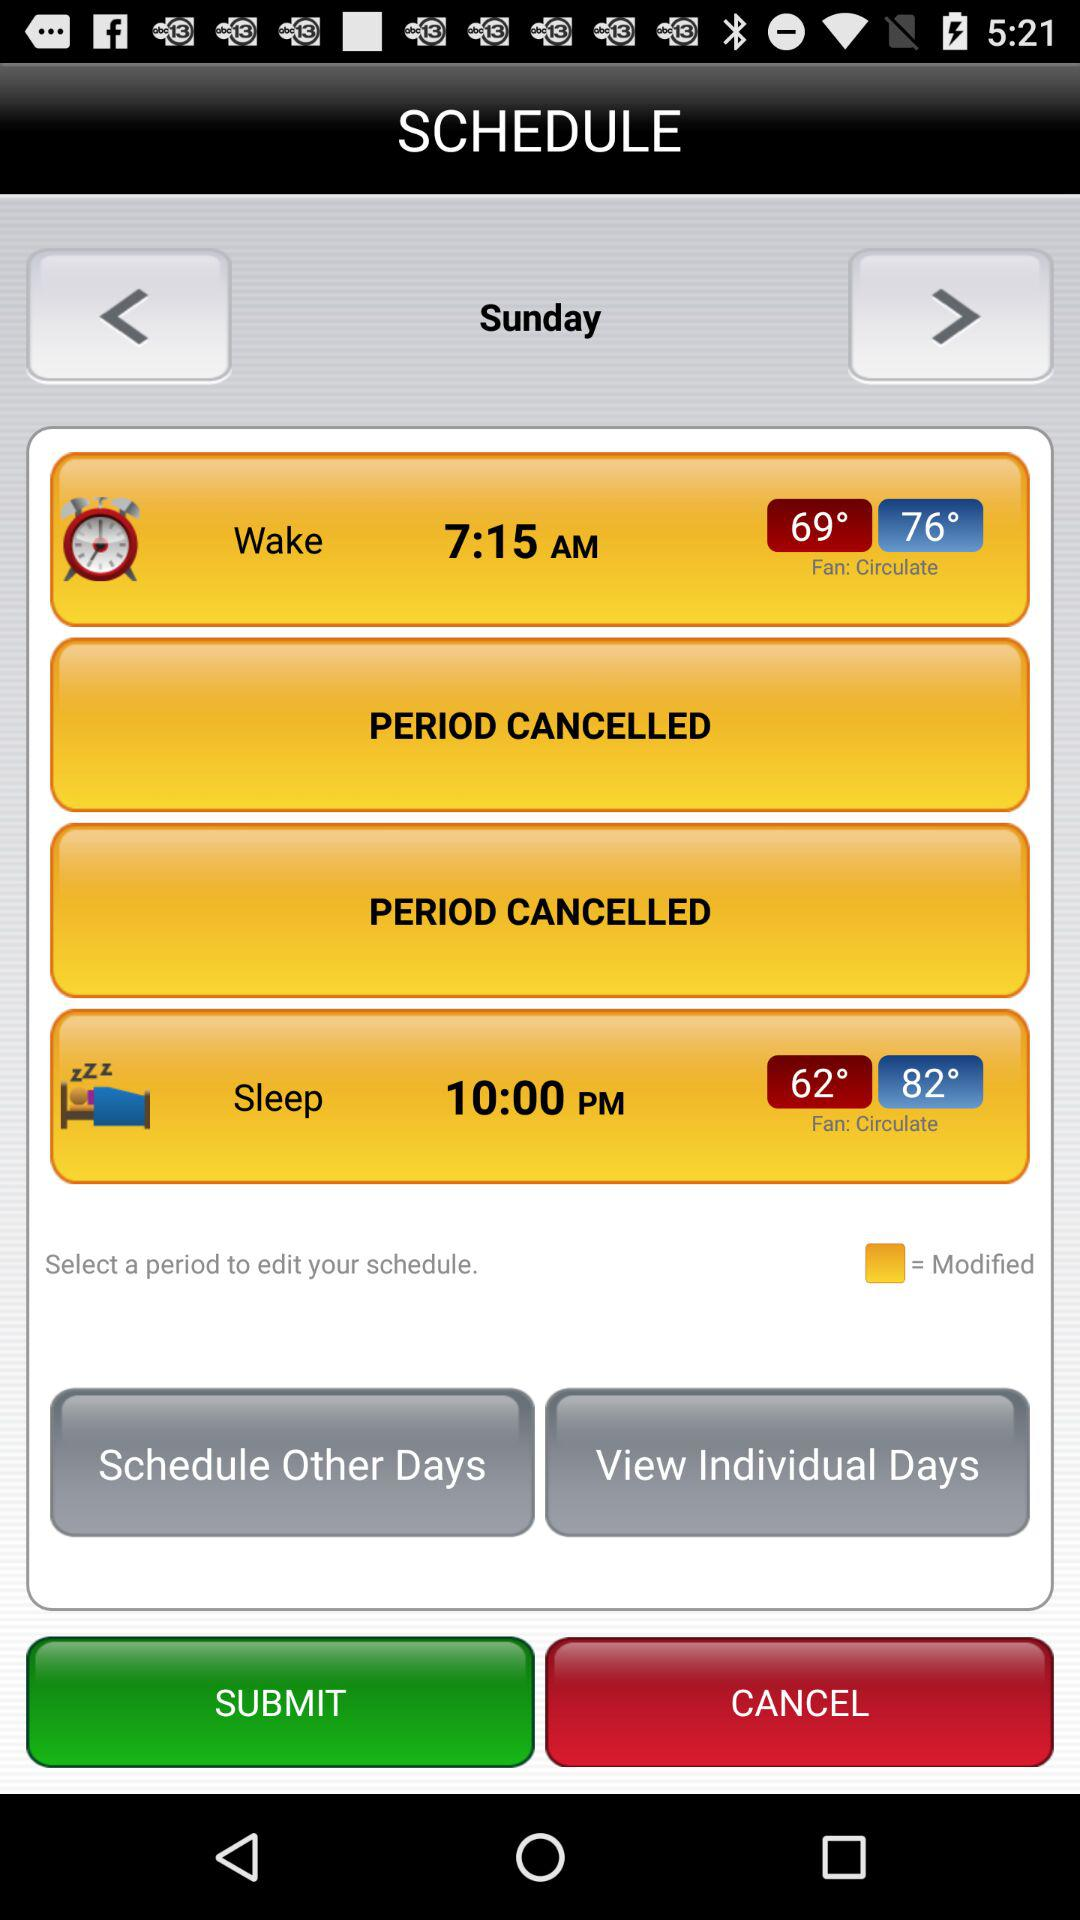What is the wake up time? The wake up time is 7:15 a.m. 